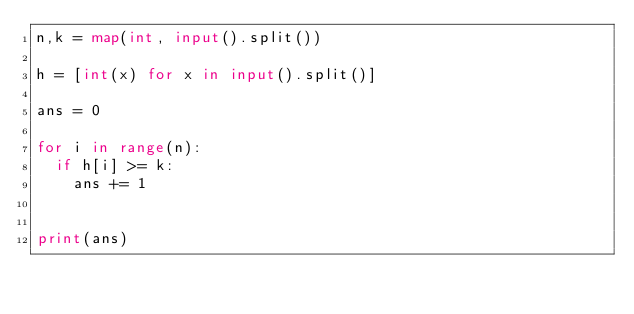<code> <loc_0><loc_0><loc_500><loc_500><_Python_>n,k = map(int, input().split())

h = [int(x) for x in input().split()]

ans = 0

for i in range(n):
	if h[i] >= k:
		ans += 1


print(ans)</code> 